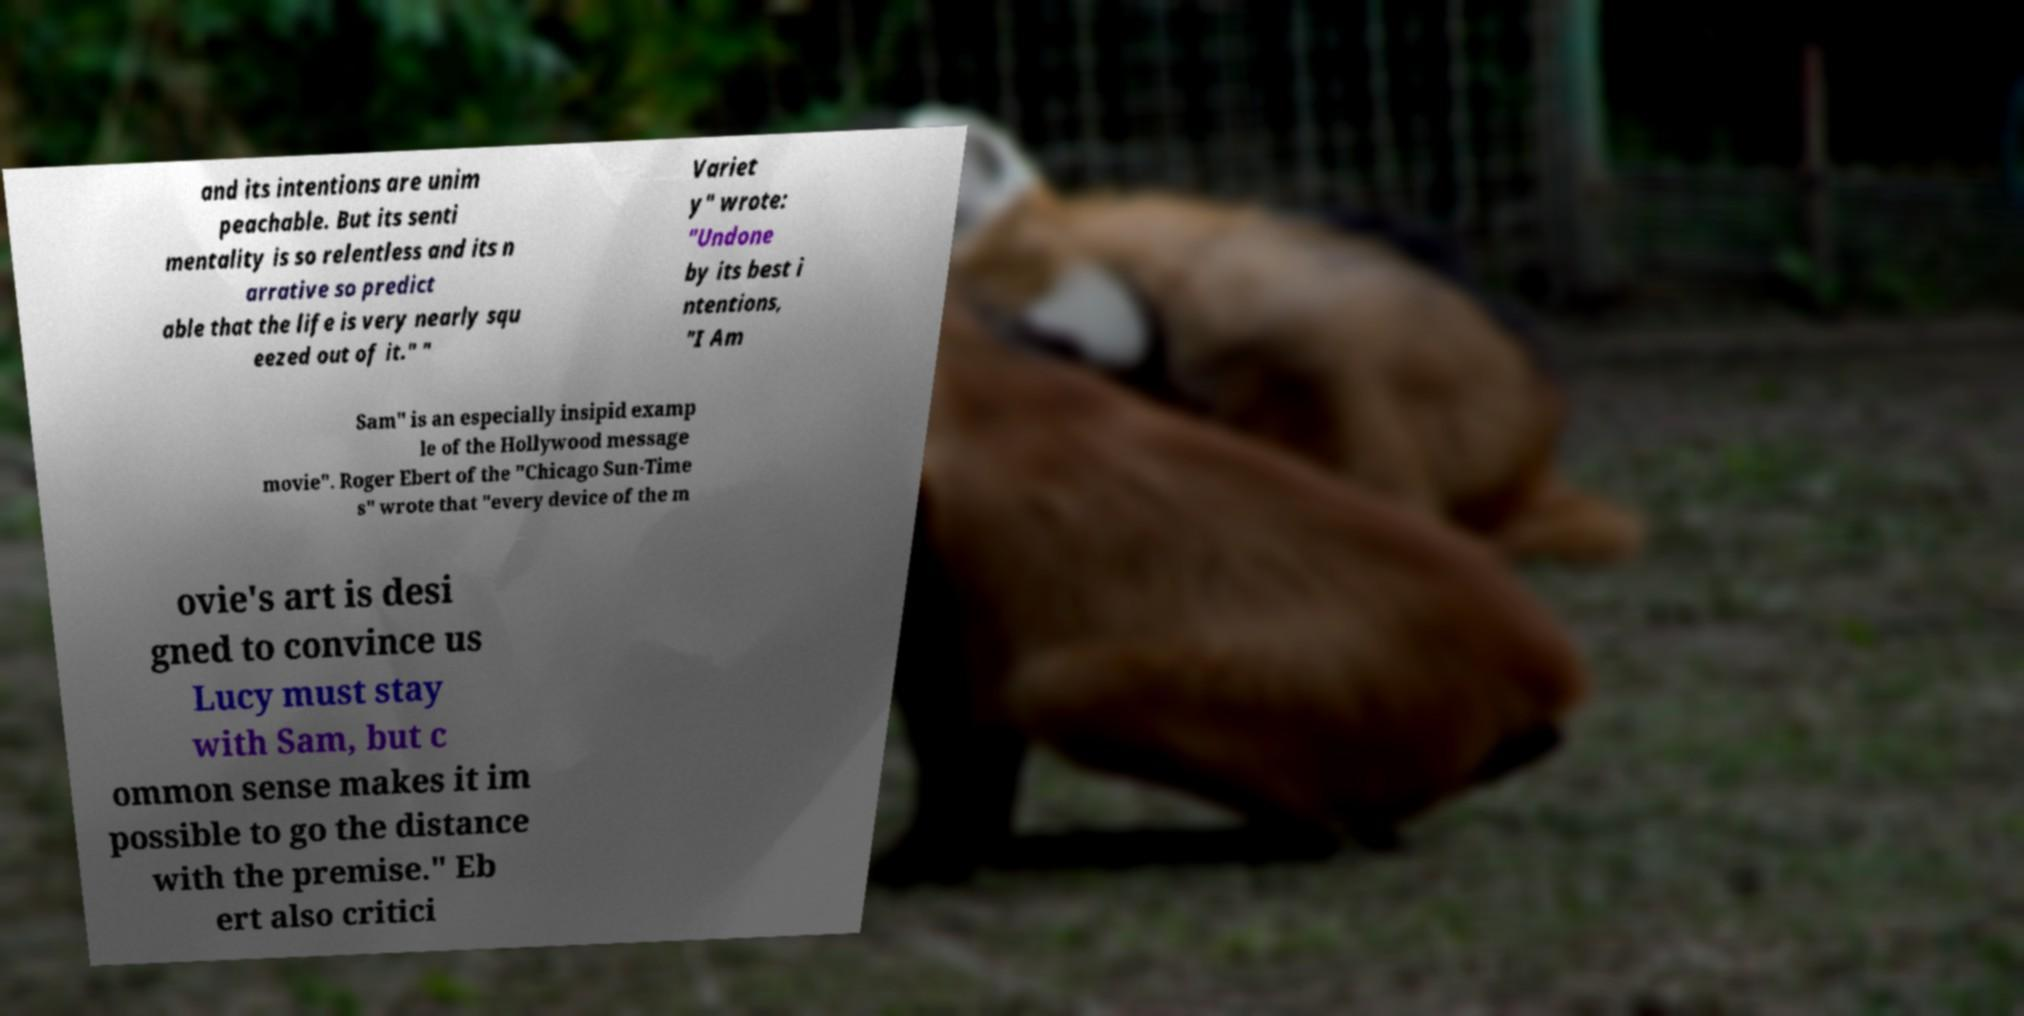There's text embedded in this image that I need extracted. Can you transcribe it verbatim? and its intentions are unim peachable. But its senti mentality is so relentless and its n arrative so predict able that the life is very nearly squ eezed out of it." " Variet y" wrote: "Undone by its best i ntentions, "I Am Sam" is an especially insipid examp le of the Hollywood message movie". Roger Ebert of the "Chicago Sun-Time s" wrote that "every device of the m ovie's art is desi gned to convince us Lucy must stay with Sam, but c ommon sense makes it im possible to go the distance with the premise." Eb ert also critici 